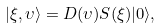<formula> <loc_0><loc_0><loc_500><loc_500>| \xi , \upsilon \rangle = D ( \upsilon ) S ( \xi ) | 0 \rangle ,</formula> 